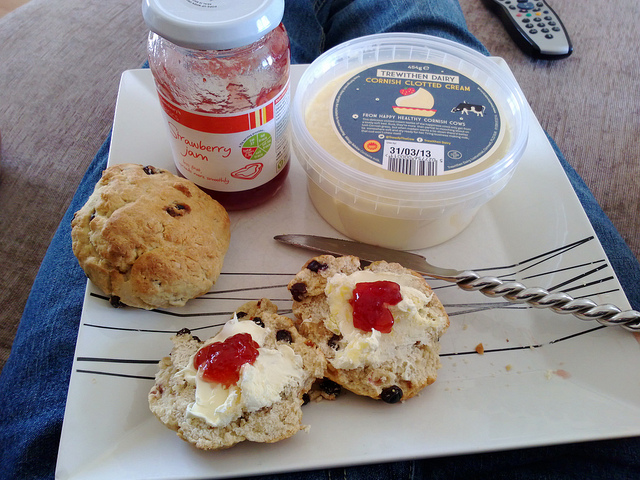<image>What type of fruit is the juice from? It is ambiguous what type of fruit the juice is from. It can be from strawberries or oranges. What type of fruit is the juice from? I don't know what type of fruit the juice is from. It can be either strawberry or orange. 